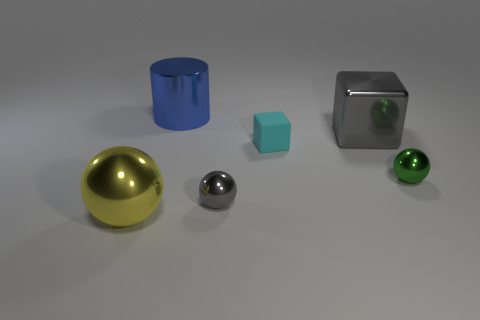What is the color of the other big object that is the same shape as the green metal object?
Provide a succinct answer. Yellow. There is a cube that is made of the same material as the small green object; what color is it?
Provide a short and direct response. Gray. What number of rubber cubes are the same size as the cyan thing?
Provide a succinct answer. 0. What material is the gray cube?
Your answer should be compact. Metal. Are there more gray shiny things than gray blocks?
Your response must be concise. Yes. Is the tiny gray thing the same shape as the tiny green thing?
Give a very brief answer. Yes. Is there any other thing that is the same shape as the blue thing?
Ensure brevity in your answer.  No. Does the large object that is on the left side of the blue metal thing have the same color as the small thing to the left of the tiny rubber cube?
Offer a very short reply. No. Is the number of small green objects that are in front of the small gray sphere less than the number of shiny objects that are behind the big block?
Your answer should be very brief. Yes. The large thing behind the big cube has what shape?
Provide a succinct answer. Cylinder. 